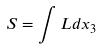Convert formula to latex. <formula><loc_0><loc_0><loc_500><loc_500>S = \int L d x _ { 3 }</formula> 